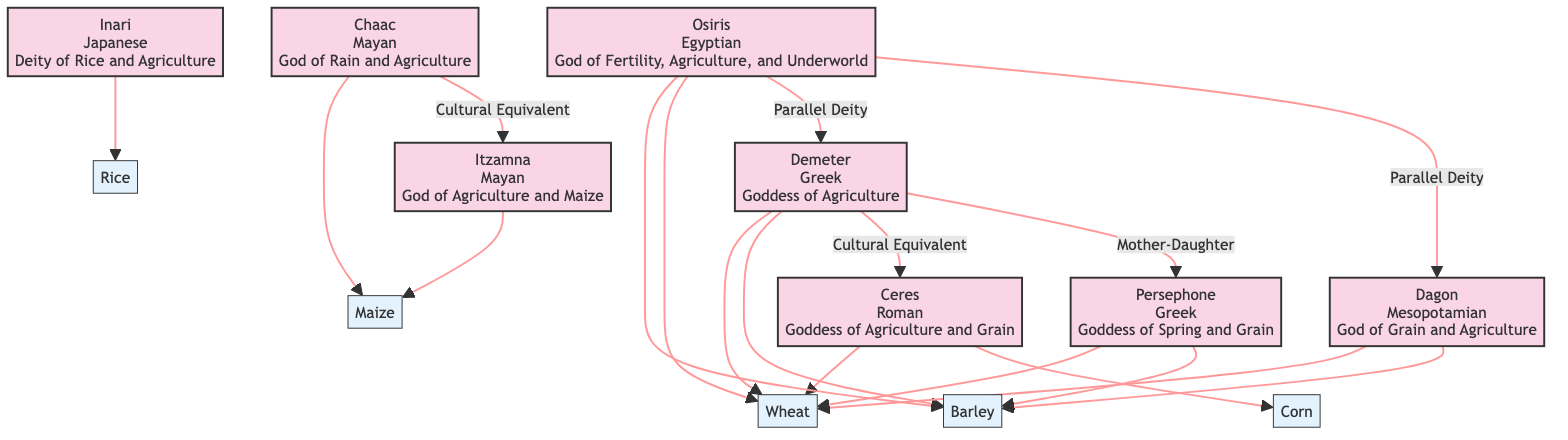What is the origin of Demeter? The diagram indicates that Demeter's origin is Greek as mentioned in the deity's description.
Answer: Greek How many associated crops does Inari have? By examining the diagram, Inari is linked to only one crop, rice, therefore it has one associated crop.
Answer: 1 Which two deities are connected by the relationship "Cultural Equivalent"? The diagram shows the connection labeled "Cultural Equivalent" between Chaac and Itzamna, indicating they share a similar significance in their respective cultures.
Answer: Chaac and Itzamna List the crops associated with Osiris. The diagram points out that Osiris is associated with barley and wheat, which can be derived from the arrows leading to these crops.
Answer: barley, wheat Who is the mother of Persephone? The relationship labeled "Mother-Daughter" in the diagram indicates that Demeter is the mother of Persephone, establishing this familial connection between them.
Answer: Demeter What type of deity is Dagon? The diagram describes Dagon as the "God of Grain and Agriculture," indicating his role and significance in agricultural practices.
Answer: God of Grain and Agriculture How many deities are affiliated with wheat? By analyzing the diagram, we can see that Demeter, Ceres, Osiris, Dagon, and Persephone are all connected to wheat, which totals five deities linked to this crop.
Answer: 5 Which two deities represent parallel deities in the diagram? The diagram identifies two parallel deity relationships involving Osiris with both Demeter and Dagon, demonstrating a shared thematic role across different cultures.
Answer: Demeter, Dagon What is the role of Itzamna? According to the diagram, Itzamna is described as the "God of Agriculture and Maize," defining his role in the context of agricultural deities.
Answer: God of Agriculture and Maize 